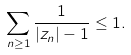Convert formula to latex. <formula><loc_0><loc_0><loc_500><loc_500>\sum _ { n \geq 1 } \frac { 1 } { | z _ { n } | - 1 } \leq 1 .</formula> 